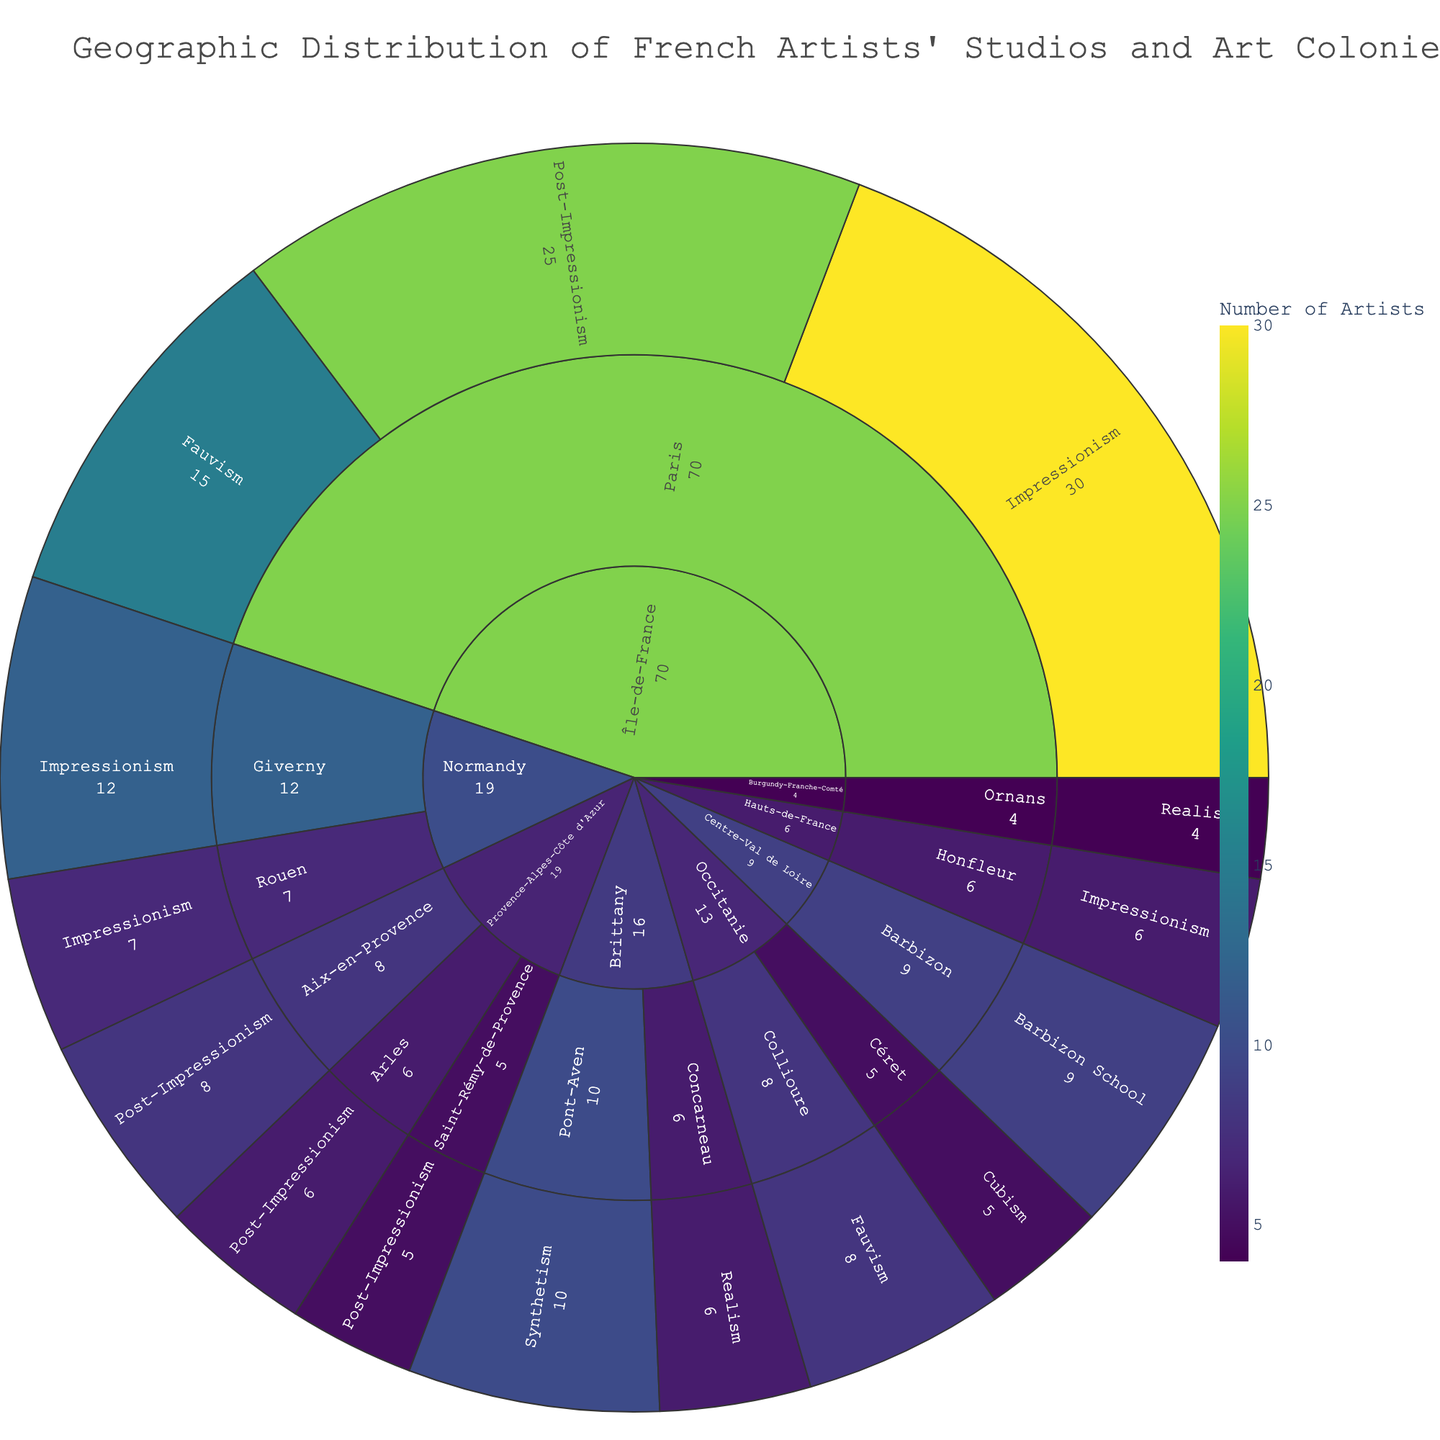What's the title of the sunburst plot? The title is usually displayed at the top of the sunburst plot. In this case, it reads: "Geographic Distribution of French Artists' Studios and Art Colonies (1870-1920)"
Answer: Geographic Distribution of French Artists' Studios and Art Colonies (1870-1920) Which region has the highest number of artists depicted in the plot? By examining the sunburst plot, you can see that Île-de-France has the largest segment, indicating it has the highest number of artists. This is due to the large number of artists located in Paris.
Answer: Île-de-France How many artists are there in Paris associated with Impressionism? You can determine the number by looking at the Paris segment in Île-de-France and then finding the Impressionism section. The number of artists shown is 30.
Answer: 30 Which art movement in Aix-en-Provence has the highest number of artists? Look at Aix-en-Provence under Provence-Alpes-Côte d'Azur and then examine the segments. The segment with the highest number of artists is Post-Impressionism with 8 artists.
Answer: Post-Impressionism Compare the number of Impressionist artists in Paris and Giverny. Which city has more artists, and by how much? Paris has 30 Impressionist artists, and Giverny has 12. Subtracting these values, Paris has 18 more Impressionist artists than Giverny.
Answer: Paris has 18 more artists If we sum the number of artists in Provence-Alpes-Côte d'Azur, what is the total? Add the number of artists across all cities in Provence-Alpes-Côte d'Azur. Aix-en-Provence has 8, Arles has 6, and Saint-Rémy-de-Provence has 5. So, 8 + 6 + 5 = 19.
Answer: 19 Which city in Brittany has the highest number of artists and which art movement do they belong to? Look at Brittany and examine the segments for each city. Pont-Aven has the highest number of artists with 10, and they are associated with Synthetism.
Answer: Pont-Aven, Synthetism What is the total number of artists associated with Realism across all regions? Sum up the artists in Concarneau (6) and Ornans (4) who are associated with Realism. Thus, 6 + 4 = 10.
Answer: 10 Which art movement in Paris has the least number of artists? In the Paris segment, compare the number of artists across different art movements. Fauvism has the least with 15 artists.
Answer: Fauvism How many distinct regions are represented in the sunburst plot? Count the outermost segments representing regions. There are 7 regions: Île-de-France, Provence-Alpes-Côte d'Azur, Normandy, Brittany, Occitanie, Burgundy-Franche-Comté, and Centre-Val de Loire.
Answer: 7 